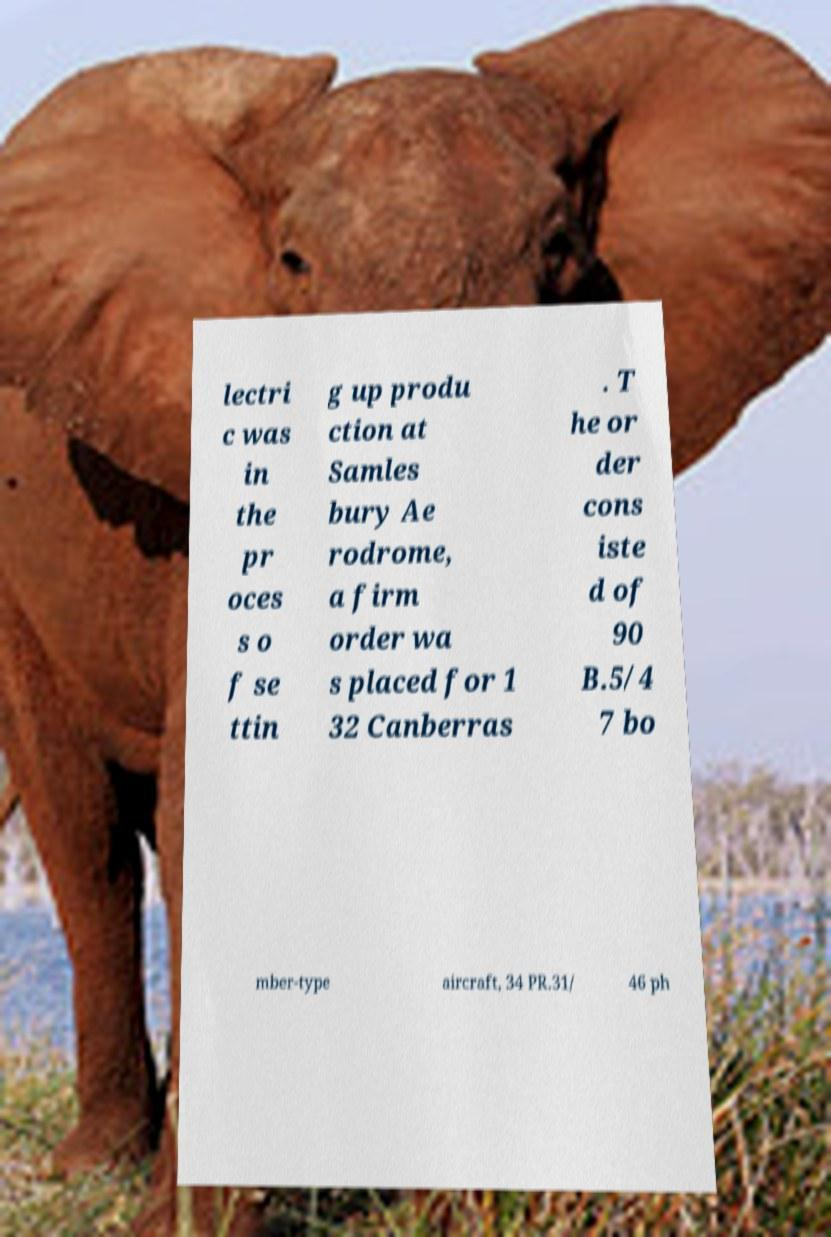Could you assist in decoding the text presented in this image and type it out clearly? lectri c was in the pr oces s o f se ttin g up produ ction at Samles bury Ae rodrome, a firm order wa s placed for 1 32 Canberras . T he or der cons iste d of 90 B.5/4 7 bo mber-type aircraft, 34 PR.31/ 46 ph 